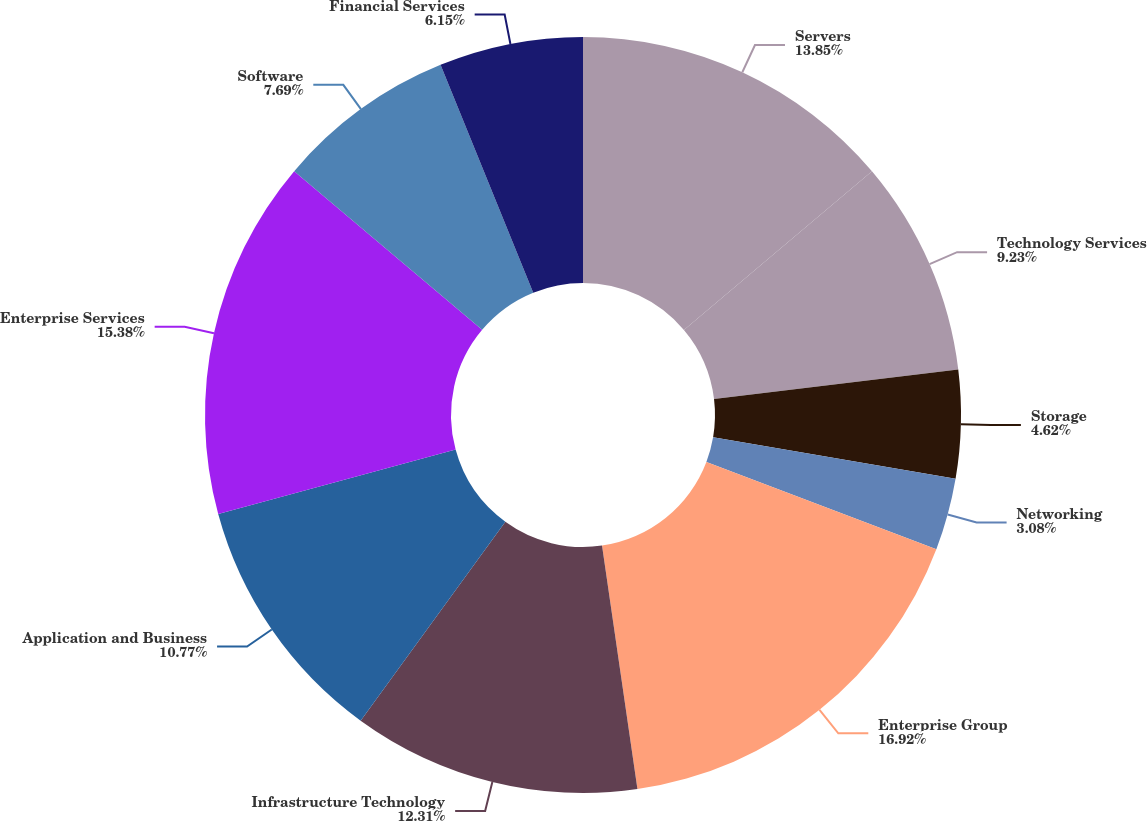Convert chart to OTSL. <chart><loc_0><loc_0><loc_500><loc_500><pie_chart><fcel>Servers<fcel>Technology Services<fcel>Storage<fcel>Networking<fcel>Enterprise Group<fcel>Infrastructure Technology<fcel>Application and Business<fcel>Enterprise Services<fcel>Software<fcel>Financial Services<nl><fcel>13.85%<fcel>9.23%<fcel>4.62%<fcel>3.08%<fcel>16.92%<fcel>12.31%<fcel>10.77%<fcel>15.38%<fcel>7.69%<fcel>6.15%<nl></chart> 